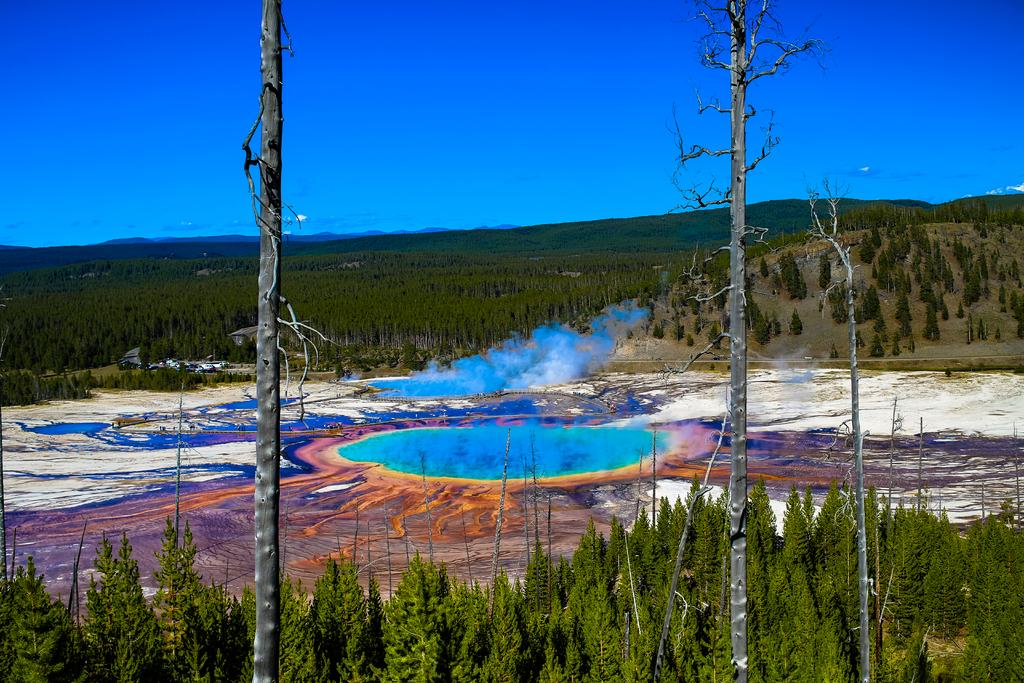What type of vegetation can be seen in the image? There are trees in the image. What is the color of the smoke in the image? The smoke in the image is blue-colored. What can be seen in the background of the image? The sky is visible in the background of the image. How many bikes are parked near the trees in the image? There are no bikes present in the image; it only features trees and blue-colored smoke. What holiday is being celebrated in the image? There is no indication of a holiday being celebrated in the image. 